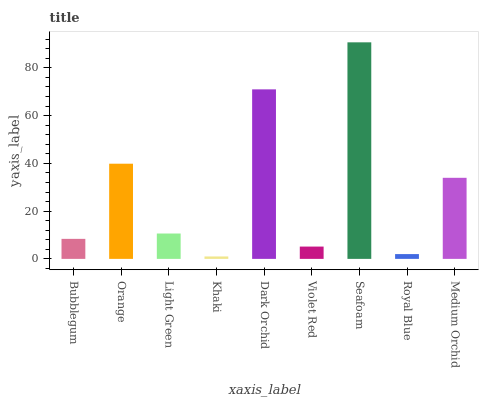Is Khaki the minimum?
Answer yes or no. Yes. Is Seafoam the maximum?
Answer yes or no. Yes. Is Orange the minimum?
Answer yes or no. No. Is Orange the maximum?
Answer yes or no. No. Is Orange greater than Bubblegum?
Answer yes or no. Yes. Is Bubblegum less than Orange?
Answer yes or no. Yes. Is Bubblegum greater than Orange?
Answer yes or no. No. Is Orange less than Bubblegum?
Answer yes or no. No. Is Light Green the high median?
Answer yes or no. Yes. Is Light Green the low median?
Answer yes or no. Yes. Is Violet Red the high median?
Answer yes or no. No. Is Bubblegum the low median?
Answer yes or no. No. 